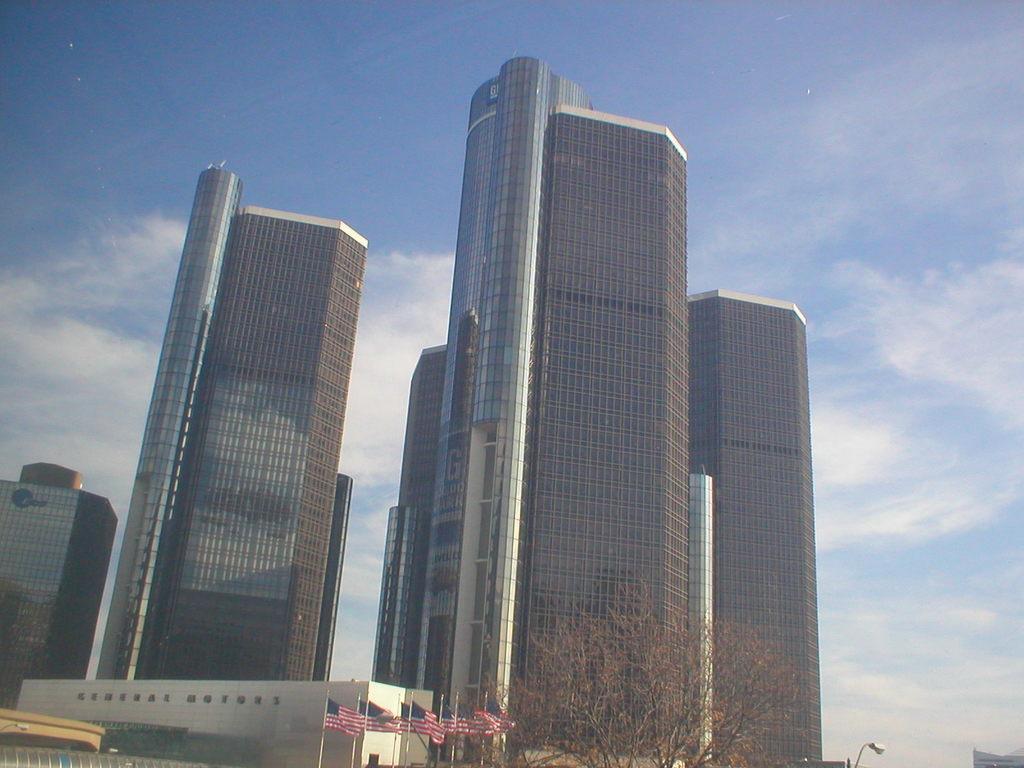How would you summarize this image in a sentence or two? In this picture we can see skyscrapers in the middle of the images. In the from bottom side we can see some american flags and dry tree. On the top we can see the sky and clouds. 